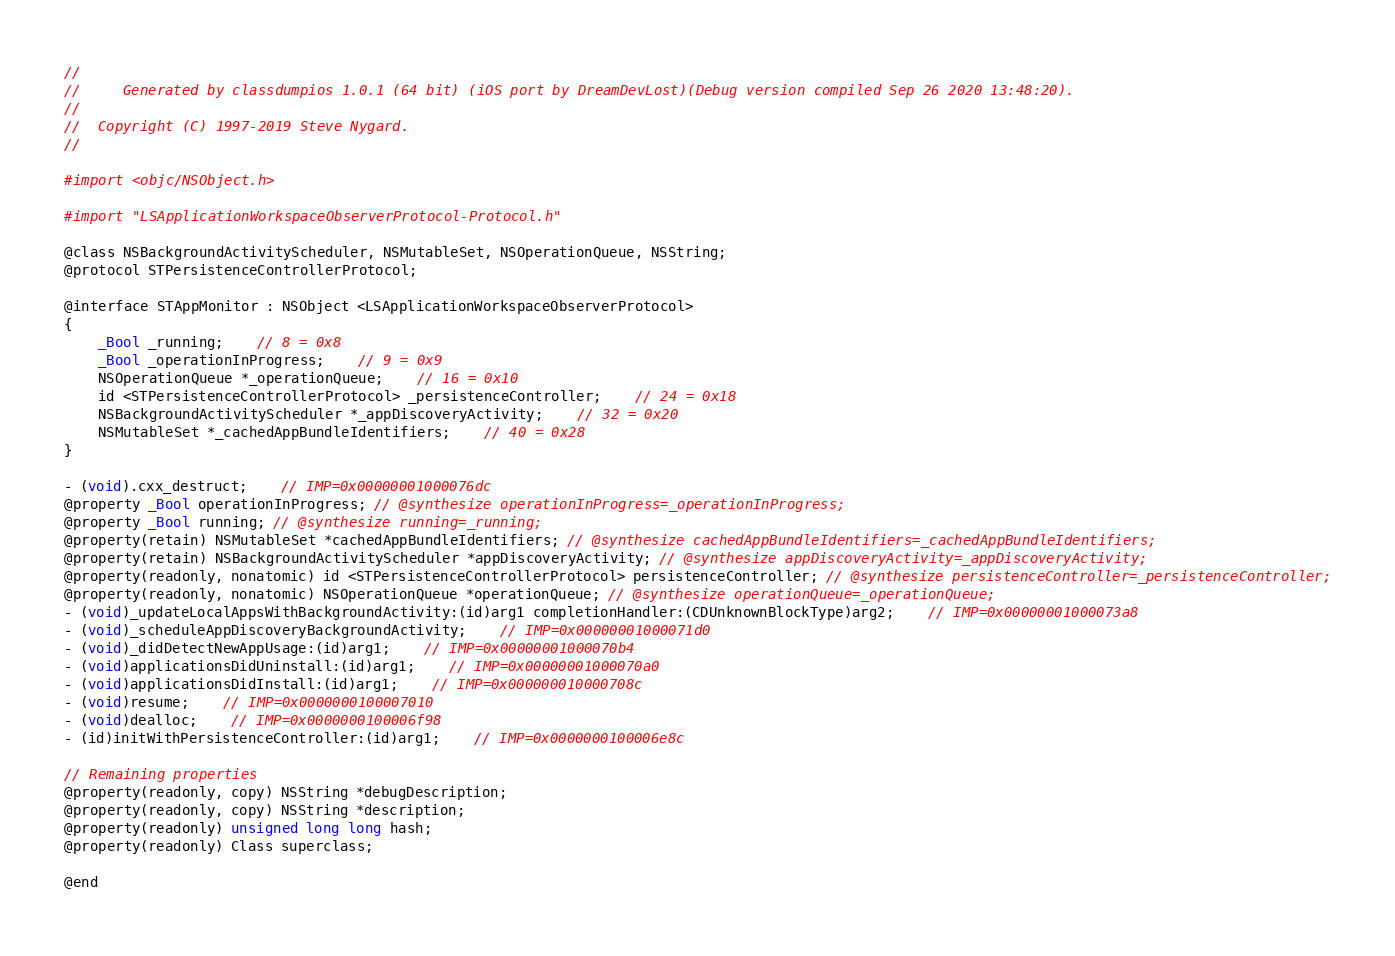Convert code to text. <code><loc_0><loc_0><loc_500><loc_500><_C_>//
//     Generated by classdumpios 1.0.1 (64 bit) (iOS port by DreamDevLost)(Debug version compiled Sep 26 2020 13:48:20).
//
//  Copyright (C) 1997-2019 Steve Nygard.
//

#import <objc/NSObject.h>

#import "LSApplicationWorkspaceObserverProtocol-Protocol.h"

@class NSBackgroundActivityScheduler, NSMutableSet, NSOperationQueue, NSString;
@protocol STPersistenceControllerProtocol;

@interface STAppMonitor : NSObject <LSApplicationWorkspaceObserverProtocol>
{
    _Bool _running;	// 8 = 0x8
    _Bool _operationInProgress;	// 9 = 0x9
    NSOperationQueue *_operationQueue;	// 16 = 0x10
    id <STPersistenceControllerProtocol> _persistenceController;	// 24 = 0x18
    NSBackgroundActivityScheduler *_appDiscoveryActivity;	// 32 = 0x20
    NSMutableSet *_cachedAppBundleIdentifiers;	// 40 = 0x28
}

- (void).cxx_destruct;	// IMP=0x00000001000076dc
@property _Bool operationInProgress; // @synthesize operationInProgress=_operationInProgress;
@property _Bool running; // @synthesize running=_running;
@property(retain) NSMutableSet *cachedAppBundleIdentifiers; // @synthesize cachedAppBundleIdentifiers=_cachedAppBundleIdentifiers;
@property(retain) NSBackgroundActivityScheduler *appDiscoveryActivity; // @synthesize appDiscoveryActivity=_appDiscoveryActivity;
@property(readonly, nonatomic) id <STPersistenceControllerProtocol> persistenceController; // @synthesize persistenceController=_persistenceController;
@property(readonly, nonatomic) NSOperationQueue *operationQueue; // @synthesize operationQueue=_operationQueue;
- (void)_updateLocalAppsWithBackgroundActivity:(id)arg1 completionHandler:(CDUnknownBlockType)arg2;	// IMP=0x00000001000073a8
- (void)_scheduleAppDiscoveryBackgroundActivity;	// IMP=0x00000001000071d0
- (void)_didDetectNewAppUsage:(id)arg1;	// IMP=0x00000001000070b4
- (void)applicationsDidUninstall:(id)arg1;	// IMP=0x00000001000070a0
- (void)applicationsDidInstall:(id)arg1;	// IMP=0x000000010000708c
- (void)resume;	// IMP=0x0000000100007010
- (void)dealloc;	// IMP=0x0000000100006f98
- (id)initWithPersistenceController:(id)arg1;	// IMP=0x0000000100006e8c

// Remaining properties
@property(readonly, copy) NSString *debugDescription;
@property(readonly, copy) NSString *description;
@property(readonly) unsigned long long hash;
@property(readonly) Class superclass;

@end

</code> 